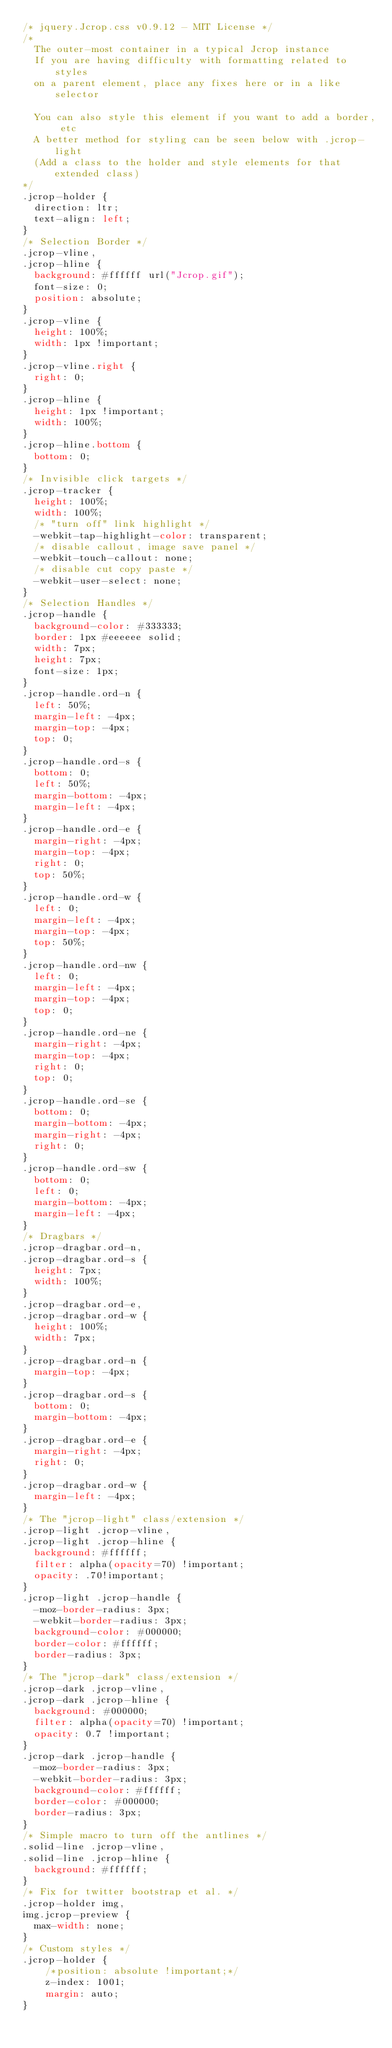Convert code to text. <code><loc_0><loc_0><loc_500><loc_500><_CSS_>/* jquery.Jcrop.css v0.9.12 - MIT License */
/*
  The outer-most container in a typical Jcrop instance
  If you are having difficulty with formatting related to styles
  on a parent element, place any fixes here or in a like selector

  You can also style this element if you want to add a border, etc
  A better method for styling can be seen below with .jcrop-light
  (Add a class to the holder and style elements for that extended class)
*/
.jcrop-holder {
  direction: ltr;
  text-align: left;
}
/* Selection Border */
.jcrop-vline,
.jcrop-hline {
  background: #ffffff url("Jcrop.gif");
  font-size: 0;
  position: absolute;
}
.jcrop-vline {
  height: 100%;
  width: 1px !important;
}
.jcrop-vline.right {
  right: 0;
}
.jcrop-hline {
  height: 1px !important;
  width: 100%;
}
.jcrop-hline.bottom {
  bottom: 0;
}
/* Invisible click targets */
.jcrop-tracker {
  height: 100%;
  width: 100%;
  /* "turn off" link highlight */
  -webkit-tap-highlight-color: transparent;
  /* disable callout, image save panel */
  -webkit-touch-callout: none;
  /* disable cut copy paste */
  -webkit-user-select: none;
}
/* Selection Handles */
.jcrop-handle {
  background-color: #333333;
  border: 1px #eeeeee solid;
  width: 7px;
  height: 7px;
  font-size: 1px;
}
.jcrop-handle.ord-n {
  left: 50%;
  margin-left: -4px;
  margin-top: -4px;
  top: 0;
}
.jcrop-handle.ord-s {
  bottom: 0;
  left: 50%;
  margin-bottom: -4px;
  margin-left: -4px;
}
.jcrop-handle.ord-e {
  margin-right: -4px;
  margin-top: -4px;
  right: 0;
  top: 50%;
}
.jcrop-handle.ord-w {
  left: 0;
  margin-left: -4px;
  margin-top: -4px;
  top: 50%;
}
.jcrop-handle.ord-nw {
  left: 0;
  margin-left: -4px;
  margin-top: -4px;
  top: 0;
}
.jcrop-handle.ord-ne {
  margin-right: -4px;
  margin-top: -4px;
  right: 0;
  top: 0;
}
.jcrop-handle.ord-se {
  bottom: 0;
  margin-bottom: -4px;
  margin-right: -4px;
  right: 0;
}
.jcrop-handle.ord-sw {
  bottom: 0;
  left: 0;
  margin-bottom: -4px;
  margin-left: -4px;
}
/* Dragbars */
.jcrop-dragbar.ord-n,
.jcrop-dragbar.ord-s {
  height: 7px;
  width: 100%;
}
.jcrop-dragbar.ord-e,
.jcrop-dragbar.ord-w {
  height: 100%;
  width: 7px;
}
.jcrop-dragbar.ord-n {
  margin-top: -4px;
}
.jcrop-dragbar.ord-s {
  bottom: 0;
  margin-bottom: -4px;
}
.jcrop-dragbar.ord-e {
  margin-right: -4px;
  right: 0;
}
.jcrop-dragbar.ord-w {
  margin-left: -4px;
}
/* The "jcrop-light" class/extension */
.jcrop-light .jcrop-vline,
.jcrop-light .jcrop-hline {
  background: #ffffff;
  filter: alpha(opacity=70) !important;
  opacity: .70!important;
}
.jcrop-light .jcrop-handle {
  -moz-border-radius: 3px;
  -webkit-border-radius: 3px;
  background-color: #000000;
  border-color: #ffffff;
  border-radius: 3px;
}
/* The "jcrop-dark" class/extension */
.jcrop-dark .jcrop-vline,
.jcrop-dark .jcrop-hline {
  background: #000000;
  filter: alpha(opacity=70) !important;
  opacity: 0.7 !important;
}
.jcrop-dark .jcrop-handle {
  -moz-border-radius: 3px;
  -webkit-border-radius: 3px;
  background-color: #ffffff;
  border-color: #000000;
  border-radius: 3px;
}
/* Simple macro to turn off the antlines */
.solid-line .jcrop-vline,
.solid-line .jcrop-hline {
  background: #ffffff;
}
/* Fix for twitter bootstrap et al. */
.jcrop-holder img,
img.jcrop-preview {
  max-width: none;
}
/* Custom styles */
.jcrop-holder {
    /*position: absolute !important;*/
    z-index: 1001;
    margin: auto;
}</code> 